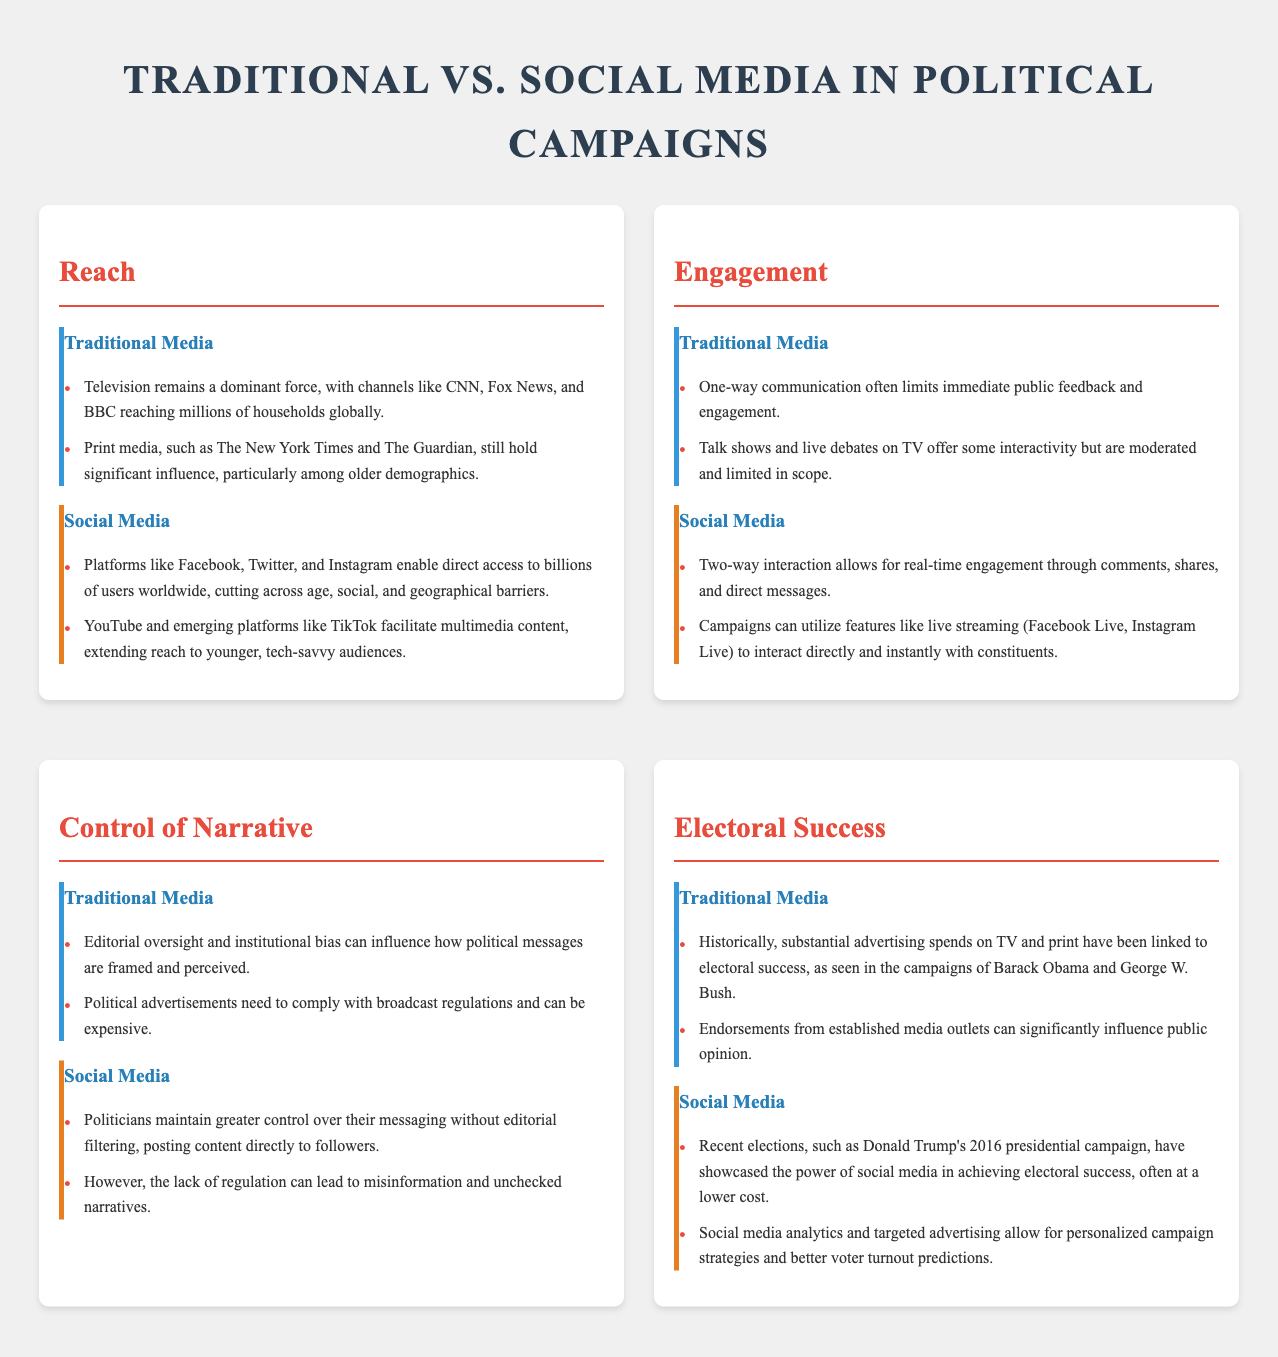What is the main medium dominating reach in traditional media? Traditional media's reach is dominated by television, with channels like CNN, Fox News, and BBC reaching millions globally.
Answer: Television Which platforms are pivotal for social media engagement? Social media engagement is driven by platforms like Facebook, Twitter, and Instagram that enable two-way interaction.
Answer: Facebook, Twitter, Instagram How does traditional media limit audience engagement? Traditional media engages audiences primarily through one-way communication, limiting immediate feedback and engagement.
Answer: One-way communication What aspect of narrative control does traditional media have? Traditional media has editorial oversight that can influence how political messages are framed and perceived.
Answer: Editorial oversight What was significant about Donald Trump's 2016 campaign in terms of social media? Donald Trump's 2016 campaign showcased the effective use of social media in achieving electoral success.
Answer: Social media What is the influence of established media endorsements on traditional media electoral success? Endorsements from established media outlets can significantly influence public opinion, contributing to electoral success.
Answer: Public opinion Which social media feature allows for direct interaction during campaigns? Campaigns can utilize live streaming features on social media platforms to interact directly with constituents.
Answer: Live streaming What signifies traditional media's substantial advertising impact? Substantial advertising spends on TV and print have historically been linked to electoral success.
Answer: Advertising spends What type of content extending reach to younger audiences is mentioned for social media? Emerging platforms like TikTok are highlighted for facilitating multimedia content that extends reach to younger audiences.
Answer: Multimedia content 